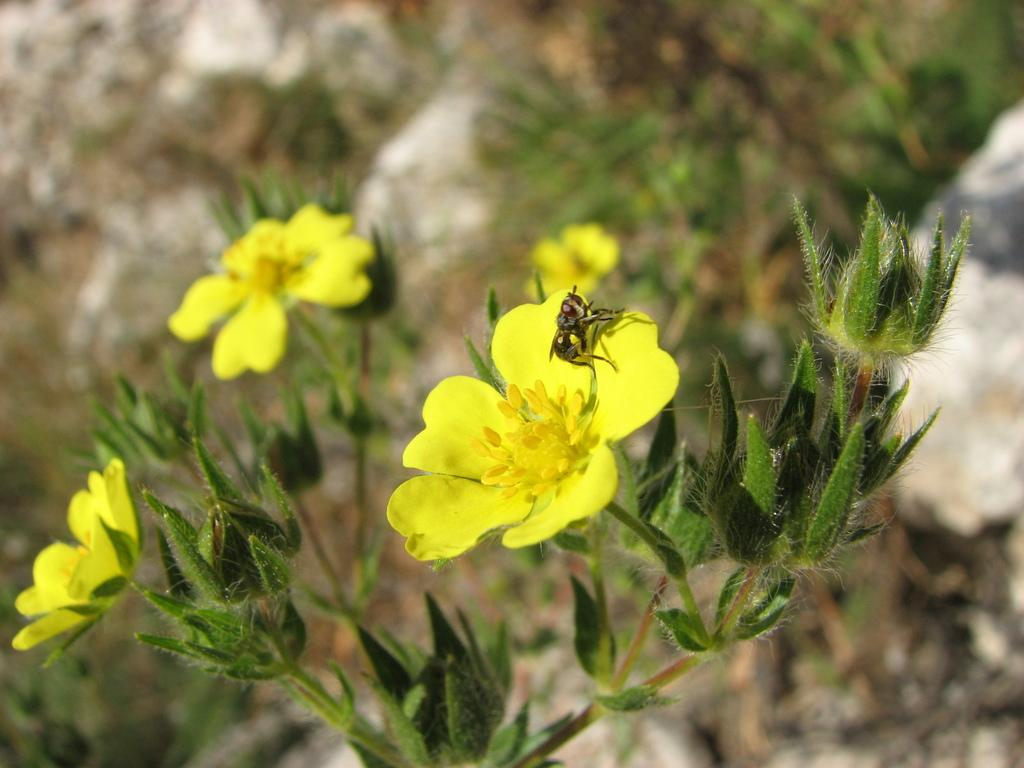What is the main subject of the picture? The main subject of the picture is an insect. Where is the insect located in the image? The insect is on a yellow flower. Can you describe the background of the image? The background of the image is slightly blurred. What other elements can be seen in the background? There are more yellow flowers of a plant visible in the background. What type of hose is being used to water the flowers in the image? There is no hose present in the image; it only features an insect on a yellow flower and a blurred background. 